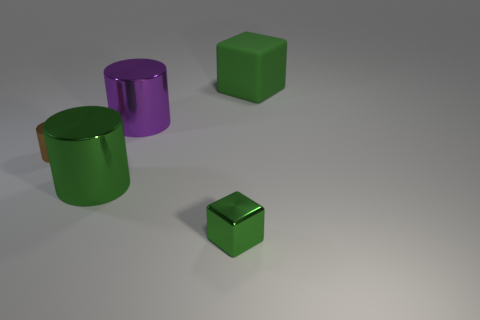Add 4 small cyan metallic balls. How many objects exist? 9 Subtract all cubes. How many objects are left? 3 Add 1 large blue metallic blocks. How many large blue metallic blocks exist? 1 Subtract 0 yellow balls. How many objects are left? 5 Subtract all green things. Subtract all tiny green cylinders. How many objects are left? 2 Add 1 tiny blocks. How many tiny blocks are left? 2 